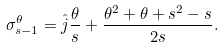Convert formula to latex. <formula><loc_0><loc_0><loc_500><loc_500>\sigma _ { s - 1 } ^ { \theta } = \hat { j } \frac { \theta } { s } + \frac { \theta ^ { 2 } + \theta + s ^ { 2 } - s } { 2 s } .</formula> 